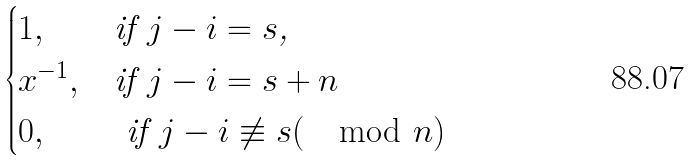<formula> <loc_0><loc_0><loc_500><loc_500>\begin{cases} 1 , & \text {if $j-i=s$,} \\ x ^ { - 1 } , & \text {if $j-i = s+n $} \\ 0 , & \text { if $j-i \not\equiv s (\mod n)$ } \end{cases}</formula> 